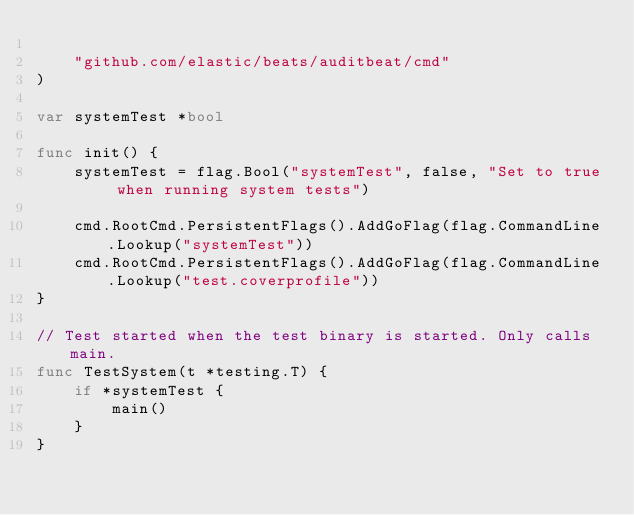<code> <loc_0><loc_0><loc_500><loc_500><_Go_>
	"github.com/elastic/beats/auditbeat/cmd"
)

var systemTest *bool

func init() {
	systemTest = flag.Bool("systemTest", false, "Set to true when running system tests")

	cmd.RootCmd.PersistentFlags().AddGoFlag(flag.CommandLine.Lookup("systemTest"))
	cmd.RootCmd.PersistentFlags().AddGoFlag(flag.CommandLine.Lookup("test.coverprofile"))
}

// Test started when the test binary is started. Only calls main.
func TestSystem(t *testing.T) {
	if *systemTest {
		main()
	}
}
</code> 